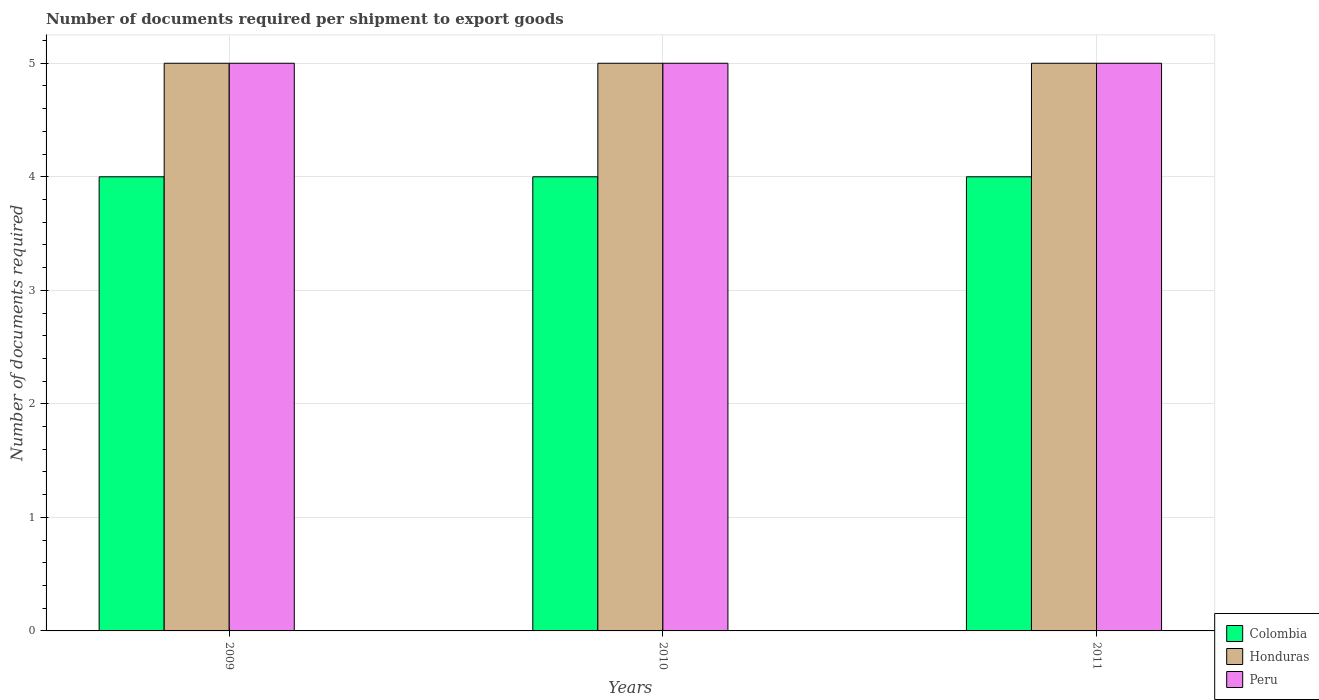How many groups of bars are there?
Make the answer very short. 3. Are the number of bars per tick equal to the number of legend labels?
Give a very brief answer. Yes. What is the label of the 2nd group of bars from the left?
Provide a short and direct response. 2010. What is the number of documents required per shipment to export goods in Honduras in 2009?
Your answer should be compact. 5. Across all years, what is the maximum number of documents required per shipment to export goods in Honduras?
Ensure brevity in your answer.  5. Across all years, what is the minimum number of documents required per shipment to export goods in Honduras?
Give a very brief answer. 5. In which year was the number of documents required per shipment to export goods in Peru maximum?
Your answer should be very brief. 2009. In which year was the number of documents required per shipment to export goods in Colombia minimum?
Your answer should be very brief. 2009. What is the total number of documents required per shipment to export goods in Honduras in the graph?
Offer a very short reply. 15. What is the difference between the number of documents required per shipment to export goods in Honduras in 2009 and that in 2010?
Offer a terse response. 0. What is the difference between the number of documents required per shipment to export goods in Peru in 2010 and the number of documents required per shipment to export goods in Honduras in 2009?
Give a very brief answer. 0. In the year 2009, what is the difference between the number of documents required per shipment to export goods in Colombia and number of documents required per shipment to export goods in Honduras?
Keep it short and to the point. -1. What is the difference between the highest and the second highest number of documents required per shipment to export goods in Colombia?
Offer a very short reply. 0. Is the sum of the number of documents required per shipment to export goods in Honduras in 2009 and 2011 greater than the maximum number of documents required per shipment to export goods in Colombia across all years?
Offer a very short reply. Yes. What does the 1st bar from the right in 2010 represents?
Provide a short and direct response. Peru. Is it the case that in every year, the sum of the number of documents required per shipment to export goods in Colombia and number of documents required per shipment to export goods in Honduras is greater than the number of documents required per shipment to export goods in Peru?
Make the answer very short. Yes. How many bars are there?
Offer a very short reply. 9. Are all the bars in the graph horizontal?
Make the answer very short. No. How many years are there in the graph?
Your response must be concise. 3. Does the graph contain grids?
Provide a succinct answer. Yes. Where does the legend appear in the graph?
Provide a succinct answer. Bottom right. How many legend labels are there?
Your answer should be compact. 3. What is the title of the graph?
Keep it short and to the point. Number of documents required per shipment to export goods. What is the label or title of the X-axis?
Your answer should be compact. Years. What is the label or title of the Y-axis?
Your response must be concise. Number of documents required. What is the Number of documents required in Peru in 2009?
Offer a terse response. 5. What is the Number of documents required of Colombia in 2010?
Provide a succinct answer. 4. Across all years, what is the maximum Number of documents required of Honduras?
Provide a short and direct response. 5. Across all years, what is the maximum Number of documents required of Peru?
Give a very brief answer. 5. Across all years, what is the minimum Number of documents required of Honduras?
Your response must be concise. 5. What is the total Number of documents required in Honduras in the graph?
Offer a very short reply. 15. What is the total Number of documents required of Peru in the graph?
Your answer should be very brief. 15. What is the difference between the Number of documents required in Colombia in 2009 and that in 2010?
Offer a very short reply. 0. What is the difference between the Number of documents required of Honduras in 2009 and that in 2010?
Offer a very short reply. 0. What is the difference between the Number of documents required of Peru in 2009 and that in 2010?
Your answer should be very brief. 0. What is the difference between the Number of documents required in Honduras in 2009 and that in 2011?
Make the answer very short. 0. What is the difference between the Number of documents required of Peru in 2009 and that in 2011?
Make the answer very short. 0. What is the difference between the Number of documents required of Peru in 2010 and that in 2011?
Your response must be concise. 0. What is the difference between the Number of documents required of Colombia in 2009 and the Number of documents required of Honduras in 2010?
Keep it short and to the point. -1. What is the difference between the Number of documents required in Honduras in 2009 and the Number of documents required in Peru in 2010?
Provide a short and direct response. 0. What is the difference between the Number of documents required of Honduras in 2009 and the Number of documents required of Peru in 2011?
Provide a short and direct response. 0. What is the difference between the Number of documents required of Colombia in 2010 and the Number of documents required of Peru in 2011?
Your answer should be compact. -1. What is the average Number of documents required in Honduras per year?
Your response must be concise. 5. In the year 2009, what is the difference between the Number of documents required in Honduras and Number of documents required in Peru?
Your answer should be compact. 0. In the year 2010, what is the difference between the Number of documents required in Colombia and Number of documents required in Honduras?
Make the answer very short. -1. In the year 2010, what is the difference between the Number of documents required of Colombia and Number of documents required of Peru?
Your answer should be very brief. -1. In the year 2010, what is the difference between the Number of documents required in Honduras and Number of documents required in Peru?
Ensure brevity in your answer.  0. In the year 2011, what is the difference between the Number of documents required of Colombia and Number of documents required of Peru?
Provide a short and direct response. -1. What is the ratio of the Number of documents required in Colombia in 2009 to that in 2010?
Provide a short and direct response. 1. What is the ratio of the Number of documents required of Peru in 2009 to that in 2010?
Ensure brevity in your answer.  1. What is the ratio of the Number of documents required in Honduras in 2009 to that in 2011?
Give a very brief answer. 1. What is the ratio of the Number of documents required of Colombia in 2010 to that in 2011?
Provide a short and direct response. 1. What is the ratio of the Number of documents required in Honduras in 2010 to that in 2011?
Offer a very short reply. 1. What is the ratio of the Number of documents required of Peru in 2010 to that in 2011?
Offer a very short reply. 1. What is the difference between the highest and the second highest Number of documents required of Colombia?
Your answer should be compact. 0. What is the difference between the highest and the lowest Number of documents required in Colombia?
Keep it short and to the point. 0. What is the difference between the highest and the lowest Number of documents required of Honduras?
Provide a short and direct response. 0. 